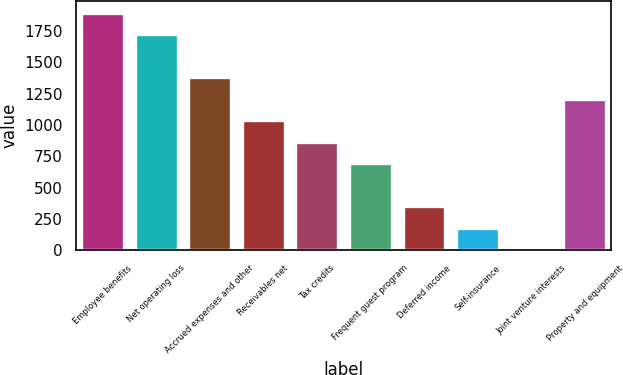<chart> <loc_0><loc_0><loc_500><loc_500><bar_chart><fcel>Employee benefits<fcel>Net operating loss<fcel>Accrued expenses and other<fcel>Receivables net<fcel>Tax credits<fcel>Frequent guest program<fcel>Deferred income<fcel>Self-insurance<fcel>Joint venture interests<fcel>Property and equipment<nl><fcel>1895.6<fcel>1724<fcel>1380.8<fcel>1037.6<fcel>866<fcel>694.4<fcel>351.2<fcel>179.6<fcel>8<fcel>1209.2<nl></chart> 